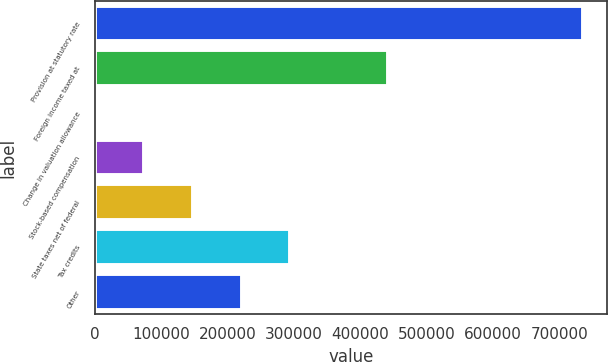Convert chart. <chart><loc_0><loc_0><loc_500><loc_500><bar_chart><fcel>Provision at statutory rate<fcel>Foreign income taxed at<fcel>Change in valuation allowance<fcel>Stock-based compensation<fcel>State taxes net of federal<fcel>Tax credits<fcel>Other<nl><fcel>734456<fcel>441044<fcel>1407<fcel>74711.9<fcel>148017<fcel>294627<fcel>221322<nl></chart> 